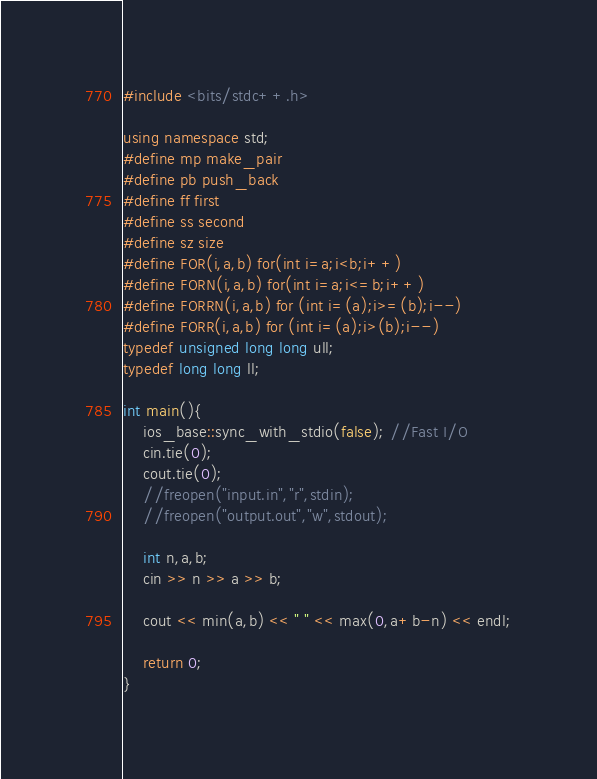<code> <loc_0><loc_0><loc_500><loc_500><_C++_>#include <bits/stdc++.h>

using namespace std;
#define mp make_pair
#define pb push_back
#define ff first
#define ss second
#define sz size
#define FOR(i,a,b) for(int i=a;i<b;i++)
#define FORN(i,a,b) for(int i=a;i<=b;i++)
#define FORRN(i,a,b) for (int i=(a);i>=(b);i--)
#define FORR(i,a,b) for (int i=(a);i>(b);i--)
typedef unsigned long long ull;
typedef long long ll;

int main(){
    ios_base::sync_with_stdio(false); //Fast I/O
    cin.tie(0);
    cout.tie(0);
	//freopen("input.in","r",stdin);
	//freopen("output.out","w",stdout);

    int n,a,b;
    cin >> n >> a >> b;

    cout << min(a,b) << " " << max(0,a+b-n) << endl;

    return 0;
}
</code> 